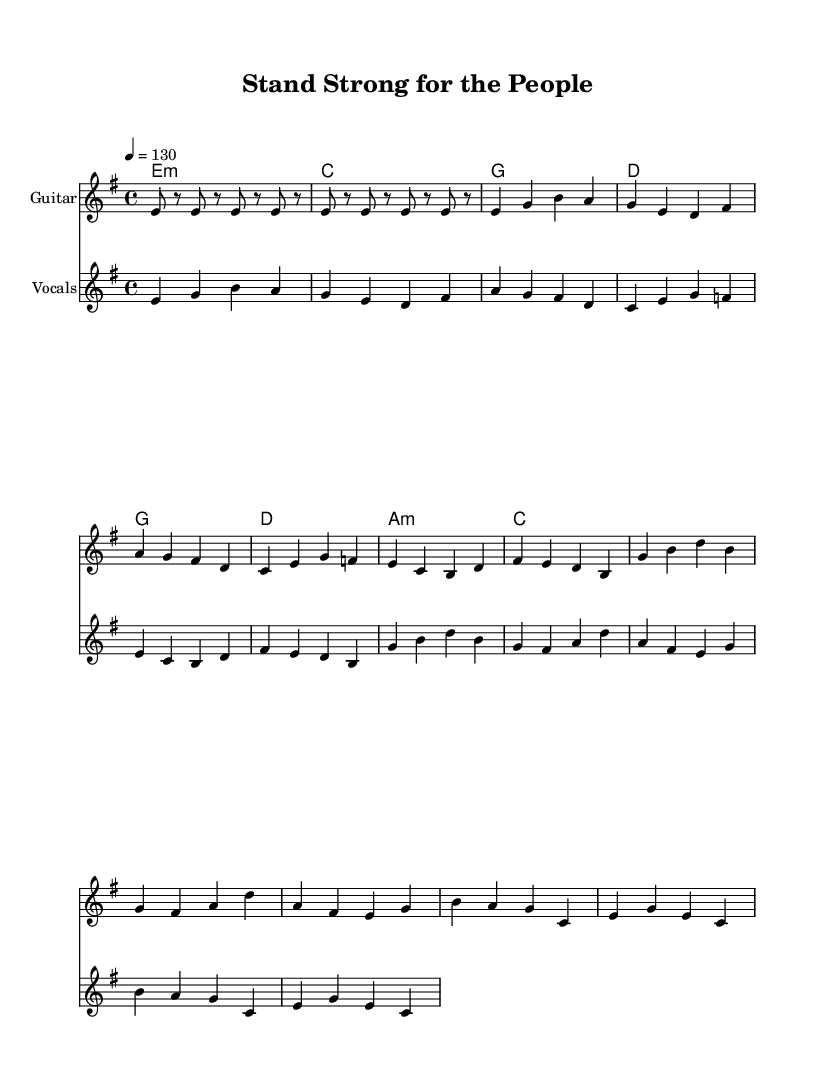What is the key signature of this music? The key signature is E minor, which is indicated by one sharp (F#) on the staff at the beginning of the score.
Answer: E minor What is the time signature of this piece? The time signature shown in the music is 4/4, meaning there are four beats per measure and the quarter note gets one beat. This is indicated at the beginning of the score.
Answer: 4/4 What is the tempo marking for this composition? The tempo marking is set at 130 beats per minute, indicated by "4 = 130" at the beginning of the score. This means the quarter note pulse will be played at this speed.
Answer: 130 How many measures are in the verse before the chorus begins? The verse contains 4 measures as seen in the melody and chords before transitioning to the chorus melody, which begins immediately afterward.
Answer: 4 What are the primary themes expressed in the lyrics? The lyrics reflect resilience and determination in public service, emphasizing standing strong and overcoming challenges, as stated in the words of the verse and chorus.
Answer: Resilience What instrument is primarily indicated for the main melody? The main melody is indicated for the Guitar, as noted in the staff label that specifies "Guitar" for that particular instrument section.
Answer: Guitar How many chords are used in the chorus section? The chorus section utilizes 4 distinct chords, which can be counted in the harmony sections labeled for the chorus part of the music.
Answer: 4 